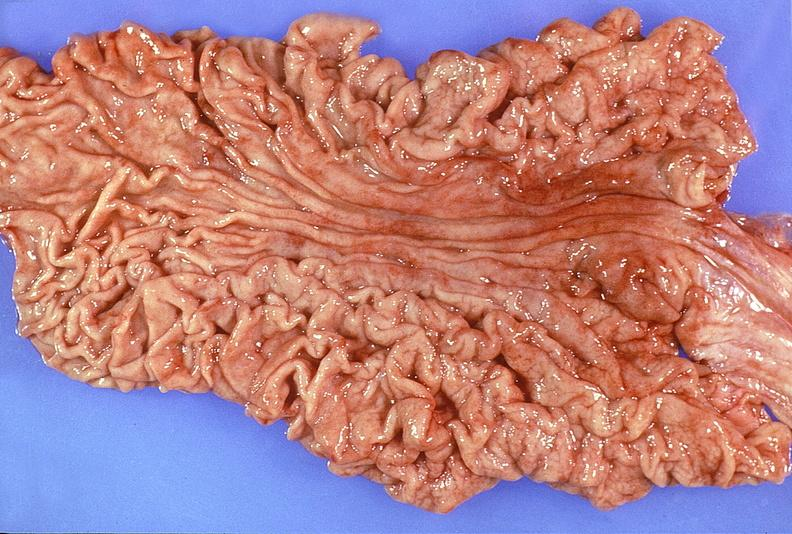s gastrointestinal present?
Answer the question using a single word or phrase. Yes 